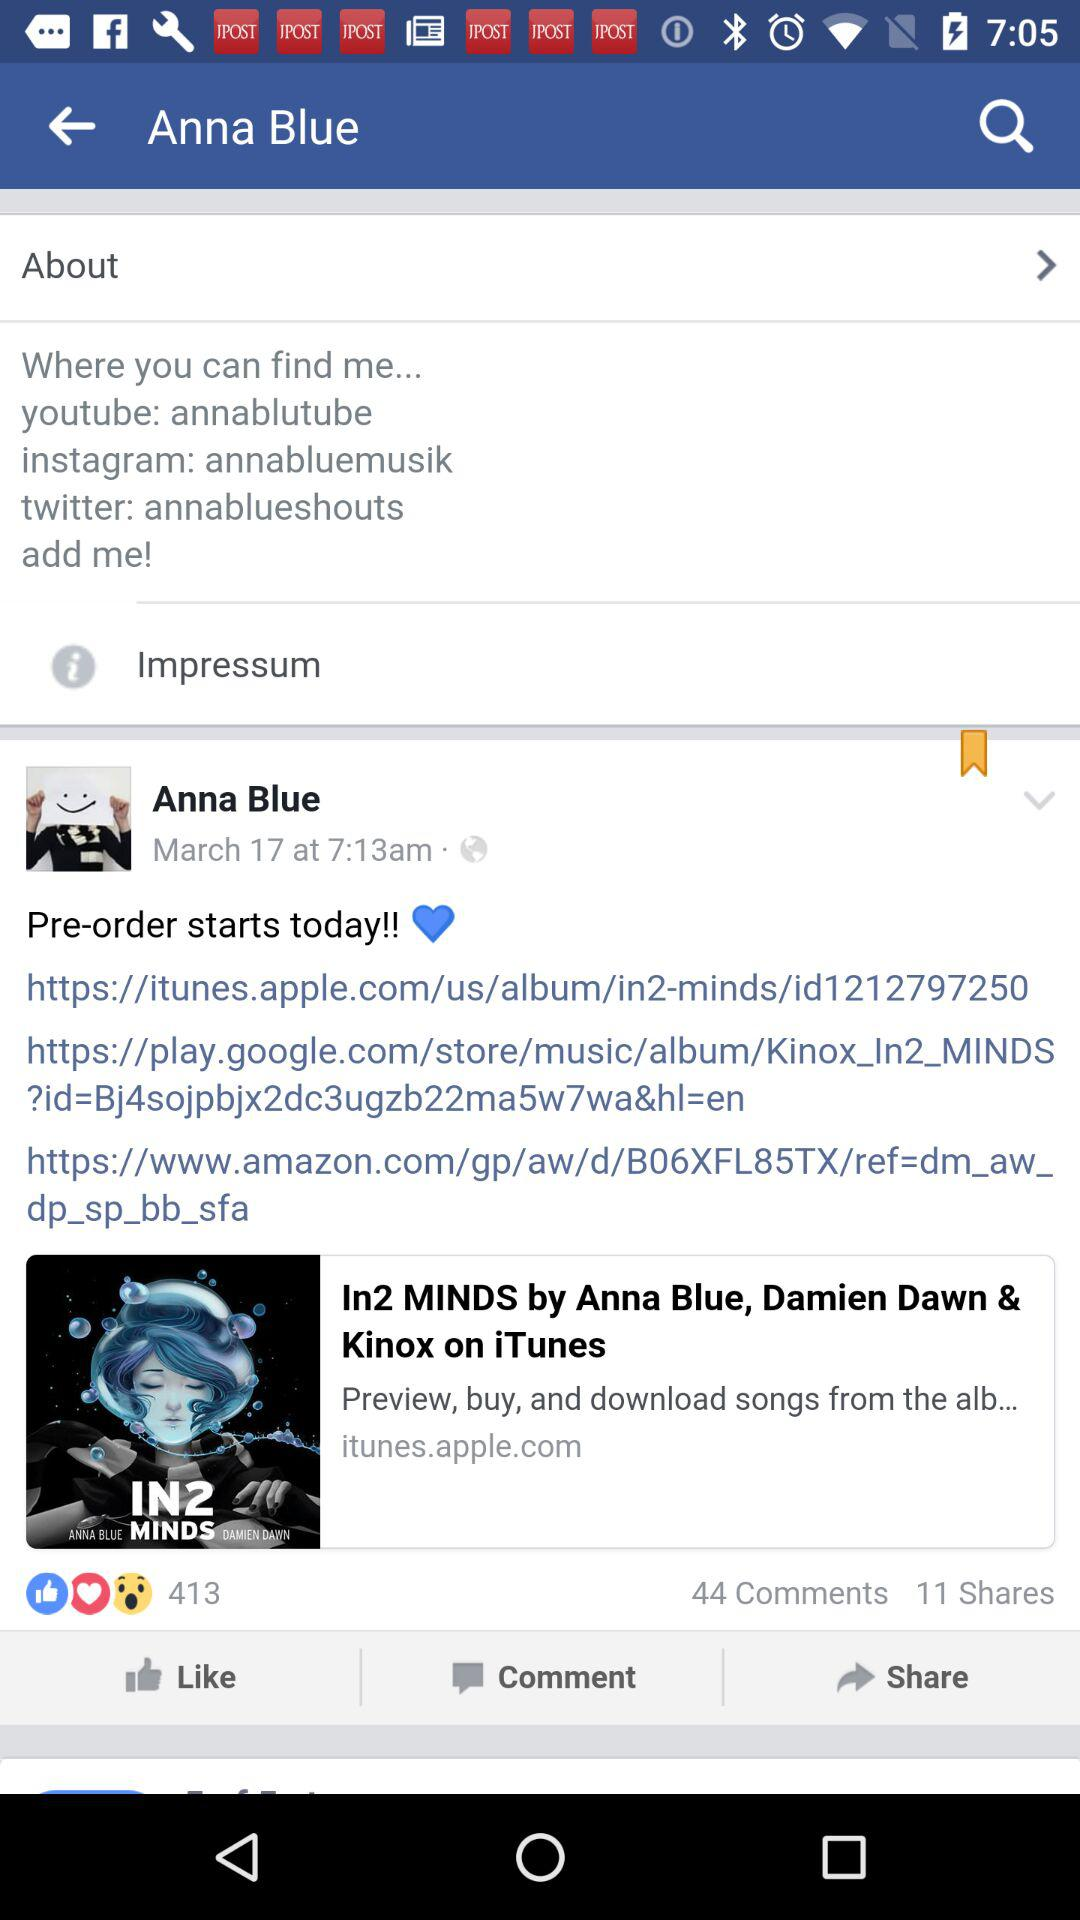What is the number of comments? The total number of comments is 44. 